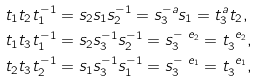<formula> <loc_0><loc_0><loc_500><loc_500>t _ { 1 } t _ { 2 } t _ { 1 } ^ { - 1 } & = s _ { 2 } s _ { 1 } s _ { 2 } ^ { - 1 } = s _ { 3 } ^ { - a } s _ { 1 } = t _ { 3 } ^ { a } t _ { 2 } , \\ t _ { 1 } t _ { 3 } t _ { 1 } ^ { - 1 } & = s _ { 2 } s _ { 3 } ^ { - 1 } s _ { 2 } ^ { - 1 } = s _ { 3 } ^ { - \ e _ { 2 } } = t _ { 3 } ^ { \ e _ { 2 } } , \\ t _ { 2 } t _ { 3 } t _ { 2 } ^ { - 1 } & = s _ { 1 } s _ { 3 } ^ { - 1 } s _ { 1 } ^ { - 1 } = s _ { 3 } ^ { - \ e _ { 1 } } = t _ { 3 } ^ { \ e _ { 1 } } ,</formula> 